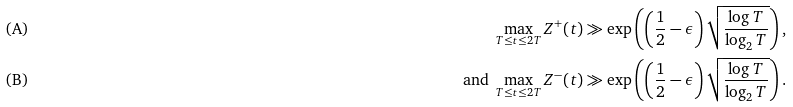Convert formula to latex. <formula><loc_0><loc_0><loc_500><loc_500>& \text {(A)} & \quad \max _ { T \leq t \leq 2 T } Z ^ { + } ( t ) \gg \exp \left ( \left ( \frac { 1 } { 2 } - \epsilon \right ) \sqrt { \frac { \log T } { \log _ { 2 } T } } \right ) , \\ & \text {(B)} & \text { and } \max _ { T \leq t \leq 2 T } Z ^ { - } ( t ) \gg \exp \left ( \left ( \frac { 1 } { 2 } - \epsilon \right ) \sqrt { \frac { \log T } { \log _ { 2 } T } } \right ) .</formula> 